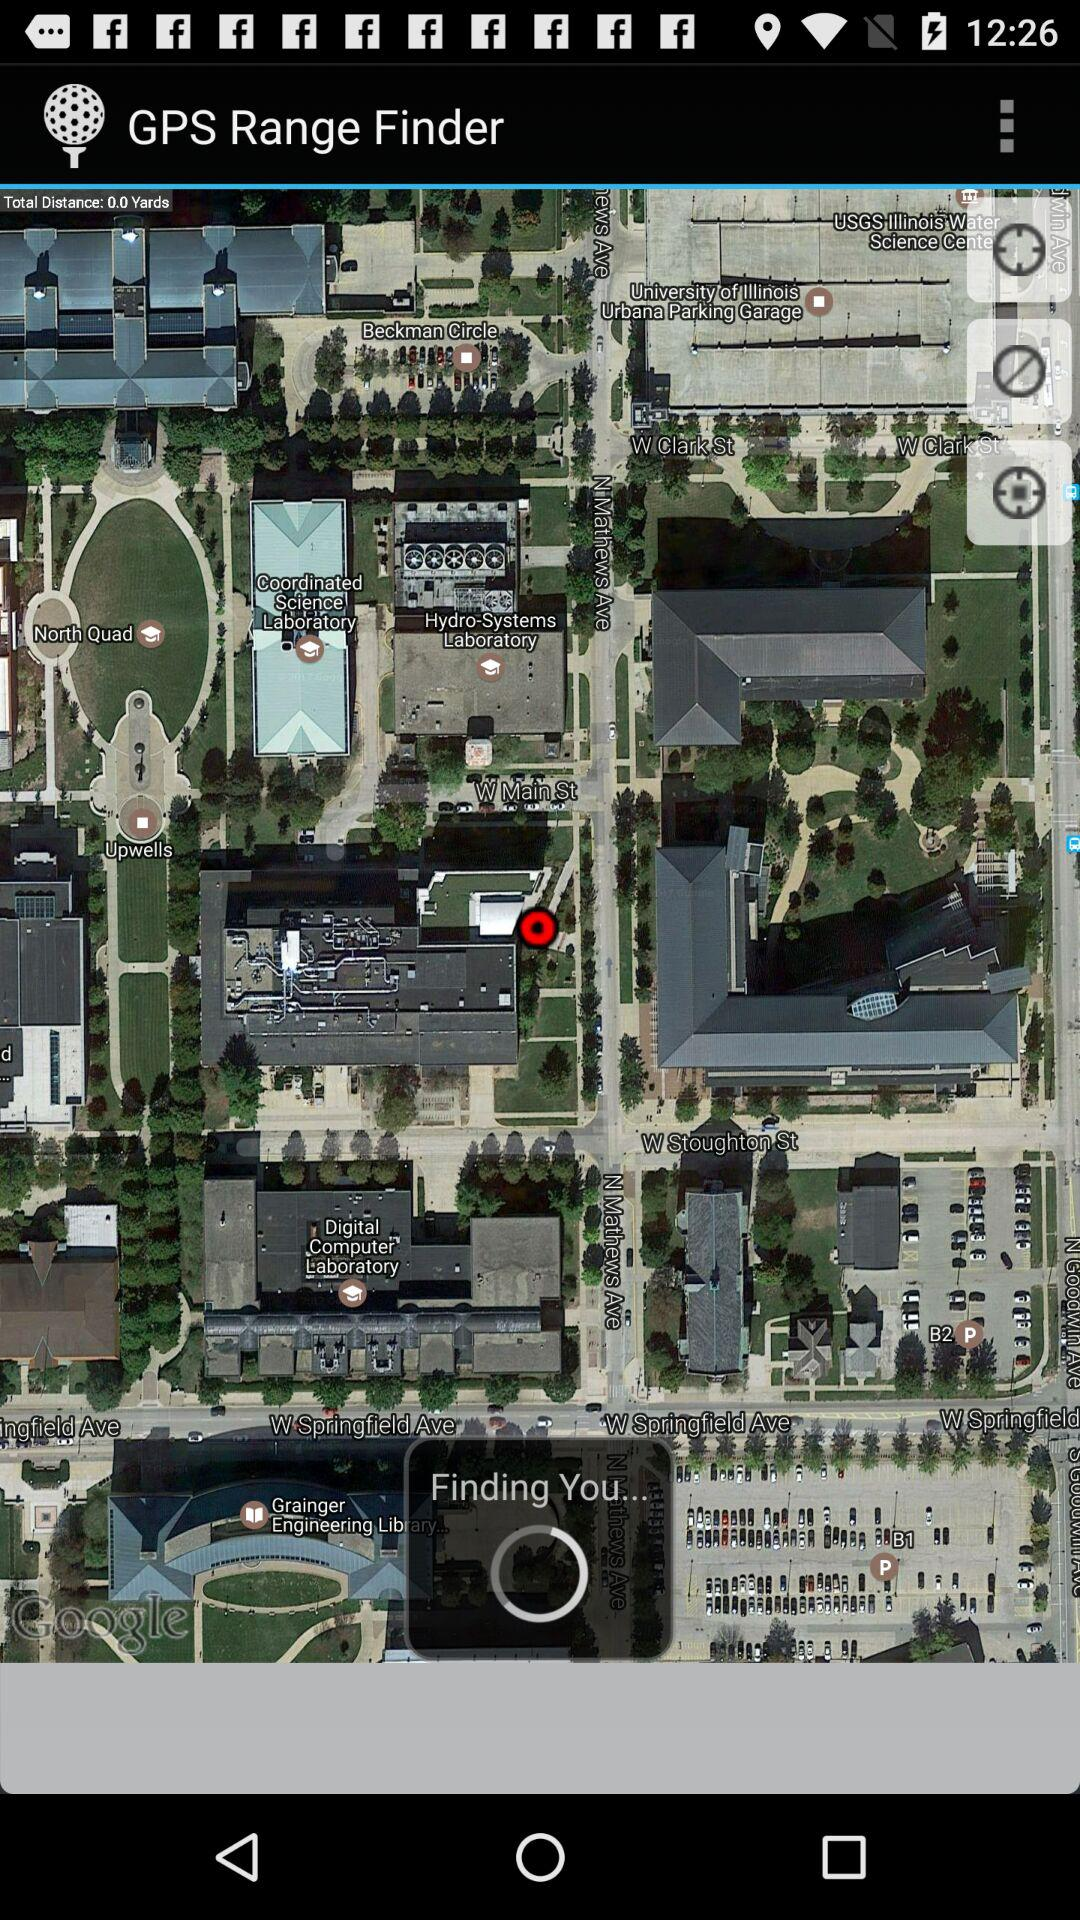How many more circles with a cross in them are there than circles with a circle in the middle?
Answer the question using a single word or phrase. 2 